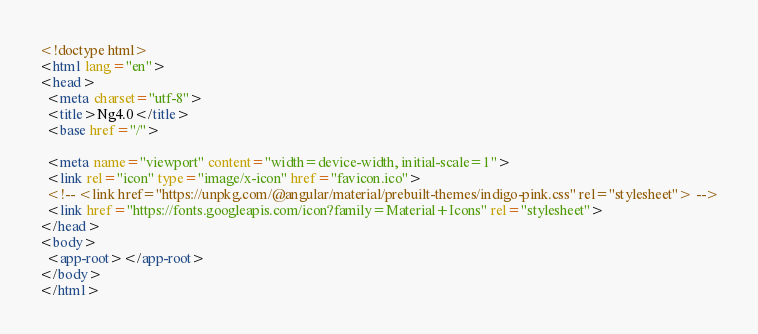<code> <loc_0><loc_0><loc_500><loc_500><_HTML_><!doctype html>
<html lang="en">
<head>
  <meta charset="utf-8">
  <title>Ng4.0</title>
  <base href="/">

  <meta name="viewport" content="width=device-width, initial-scale=1">
  <link rel="icon" type="image/x-icon" href="favicon.ico">
  <!-- <link href="https://unpkg.com/@angular/material/prebuilt-themes/indigo-pink.css" rel="stylesheet"> -->
  <link href="https://fonts.googleapis.com/icon?family=Material+Icons" rel="stylesheet">
</head>
<body>
  <app-root></app-root>
</body>
</html>
</code> 